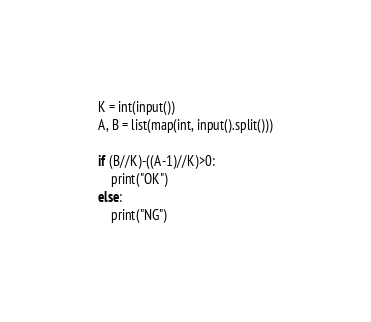Convert code to text. <code><loc_0><loc_0><loc_500><loc_500><_Python_>K = int(input())
A, B = list(map(int, input().split()))

if (B//K)-((A-1)//K)>0:
    print("OK")
else:
    print("NG")</code> 